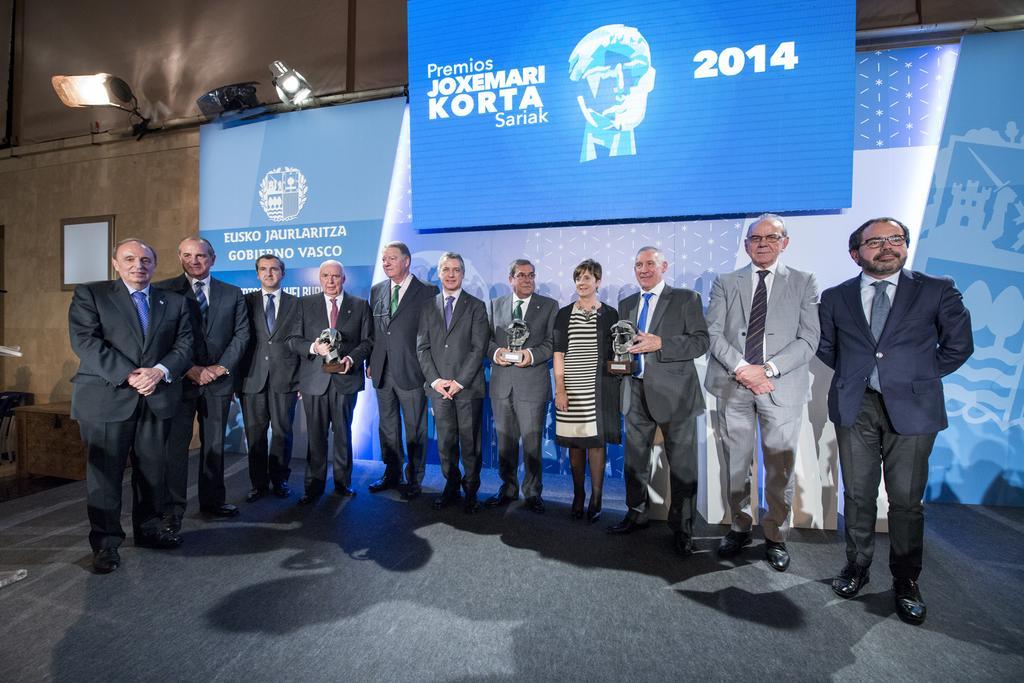Describe this image in one or two sentences. In this image we can see group of persons standing wearing suits some are holding awards and at the background of the image there is blue color sheet, lights and wall. 